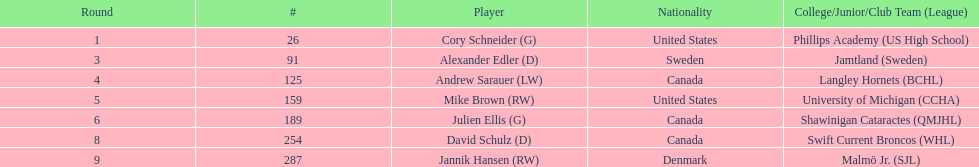Which athlete was the first one chosen in the draft? Cory Schneider (G). Would you mind parsing the complete table? {'header': ['Round', '#', 'Player', 'Nationality', 'College/Junior/Club Team (League)'], 'rows': [['1', '26', 'Cory Schneider (G)', 'United States', 'Phillips Academy (US High School)'], ['3', '91', 'Alexander Edler (D)', 'Sweden', 'Jamtland (Sweden)'], ['4', '125', 'Andrew Sarauer (LW)', 'Canada', 'Langley Hornets (BCHL)'], ['5', '159', 'Mike Brown (RW)', 'United States', 'University of Michigan (CCHA)'], ['6', '189', 'Julien Ellis (G)', 'Canada', 'Shawinigan Cataractes (QMJHL)'], ['8', '254', 'David Schulz (D)', 'Canada', 'Swift Current Broncos (WHL)'], ['9', '287', 'Jannik Hansen (RW)', 'Denmark', 'Malmö Jr. (SJL)']]} 